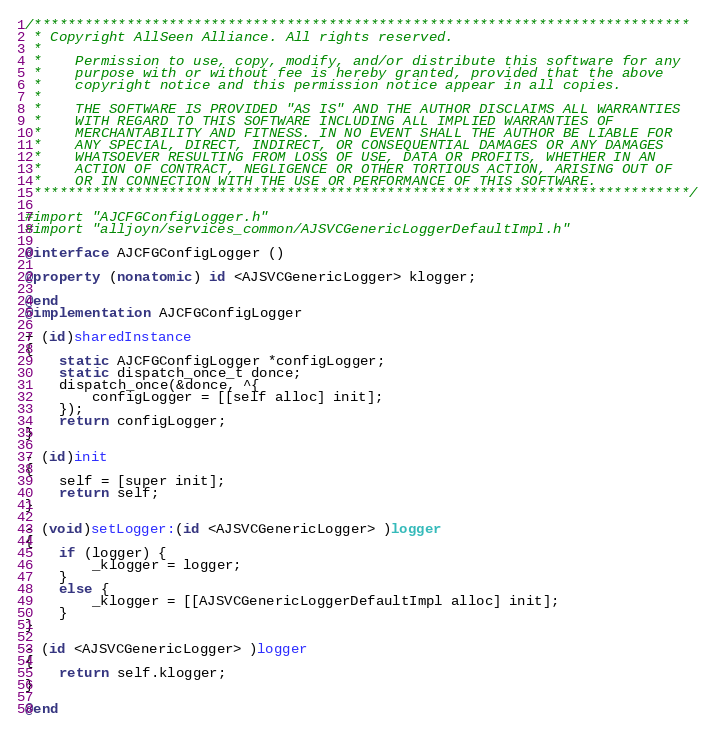Convert code to text. <code><loc_0><loc_0><loc_500><loc_500><_ObjectiveC_>/******************************************************************************
 * Copyright AllSeen Alliance. All rights reserved.
 *
 *    Permission to use, copy, modify, and/or distribute this software for any
 *    purpose with or without fee is hereby granted, provided that the above
 *    copyright notice and this permission notice appear in all copies.
 *
 *    THE SOFTWARE IS PROVIDED "AS IS" AND THE AUTHOR DISCLAIMS ALL WARRANTIES
 *    WITH REGARD TO THIS SOFTWARE INCLUDING ALL IMPLIED WARRANTIES OF
 *    MERCHANTABILITY AND FITNESS. IN NO EVENT SHALL THE AUTHOR BE LIABLE FOR
 *    ANY SPECIAL, DIRECT, INDIRECT, OR CONSEQUENTIAL DAMAGES OR ANY DAMAGES
 *    WHATSOEVER RESULTING FROM LOSS OF USE, DATA OR PROFITS, WHETHER IN AN
 *    ACTION OF CONTRACT, NEGLIGENCE OR OTHER TORTIOUS ACTION, ARISING OUT OF
 *    OR IN CONNECTION WITH THE USE OR PERFORMANCE OF THIS SOFTWARE.
 ******************************************************************************/

#import "AJCFGConfigLogger.h"
#import "alljoyn/services_common/AJSVCGenericLoggerDefaultImpl.h"

@interface AJCFGConfigLogger ()

@property (nonatomic) id <AJSVCGenericLogger> klogger;

@end
@implementation AJCFGConfigLogger

+ (id)sharedInstance
{
	static AJCFGConfigLogger *configLogger;
	static dispatch_once_t donce;
	dispatch_once(&donce, ^{
	    configLogger = [[self alloc] init];
	});
	return configLogger;
}

- (id)init
{
	self = [super init];
	return self;
}

- (void)setLogger:(id <AJSVCGenericLogger> )logger
{
	if (logger) {
		_klogger = logger;
	}
	else {
		_klogger = [[AJSVCGenericLoggerDefaultImpl alloc] init];
	}
}

- (id <AJSVCGenericLogger> )logger
{
	return self.klogger;
}

@end
</code> 